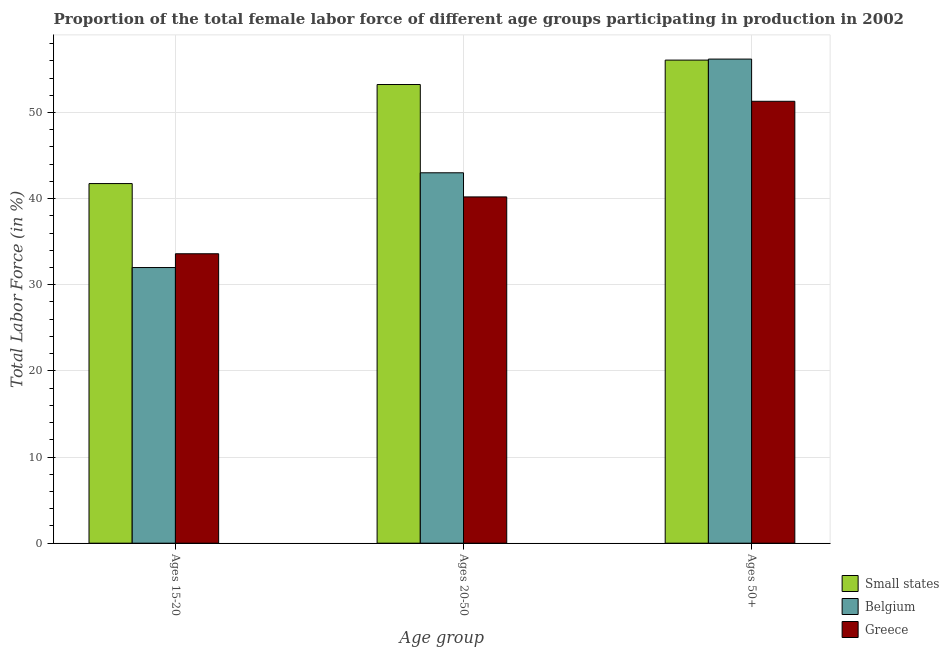How many different coloured bars are there?
Provide a succinct answer. 3. How many groups of bars are there?
Offer a terse response. 3. Are the number of bars on each tick of the X-axis equal?
Offer a terse response. Yes. How many bars are there on the 2nd tick from the left?
Give a very brief answer. 3. How many bars are there on the 3rd tick from the right?
Keep it short and to the point. 3. What is the label of the 1st group of bars from the left?
Provide a short and direct response. Ages 15-20. What is the percentage of female labor force within the age group 20-50 in Small states?
Offer a terse response. 53.25. Across all countries, what is the maximum percentage of female labor force above age 50?
Give a very brief answer. 56.2. In which country was the percentage of female labor force within the age group 20-50 maximum?
Your response must be concise. Small states. What is the total percentage of female labor force within the age group 20-50 in the graph?
Your answer should be very brief. 136.45. What is the difference between the percentage of female labor force above age 50 in Greece and that in Belgium?
Ensure brevity in your answer.  -4.9. What is the difference between the percentage of female labor force within the age group 20-50 in Belgium and the percentage of female labor force above age 50 in Small states?
Your answer should be compact. -13.08. What is the average percentage of female labor force within the age group 20-50 per country?
Give a very brief answer. 45.48. What is the difference between the percentage of female labor force within the age group 15-20 and percentage of female labor force within the age group 20-50 in Greece?
Provide a short and direct response. -6.6. What is the ratio of the percentage of female labor force within the age group 15-20 in Small states to that in Belgium?
Your answer should be compact. 1.3. Is the percentage of female labor force within the age group 20-50 in Belgium less than that in Greece?
Your answer should be very brief. No. Is the difference between the percentage of female labor force within the age group 20-50 in Belgium and Greece greater than the difference between the percentage of female labor force within the age group 15-20 in Belgium and Greece?
Ensure brevity in your answer.  Yes. What is the difference between the highest and the second highest percentage of female labor force above age 50?
Give a very brief answer. 0.12. What is the difference between the highest and the lowest percentage of female labor force above age 50?
Provide a short and direct response. 4.9. In how many countries, is the percentage of female labor force within the age group 20-50 greater than the average percentage of female labor force within the age group 20-50 taken over all countries?
Provide a short and direct response. 1. Is the sum of the percentage of female labor force within the age group 15-20 in Small states and Greece greater than the maximum percentage of female labor force within the age group 20-50 across all countries?
Make the answer very short. Yes. What does the 3rd bar from the right in Ages 15-20 represents?
Offer a terse response. Small states. Are all the bars in the graph horizontal?
Provide a short and direct response. No. What is the difference between two consecutive major ticks on the Y-axis?
Provide a short and direct response. 10. Where does the legend appear in the graph?
Keep it short and to the point. Bottom right. What is the title of the graph?
Keep it short and to the point. Proportion of the total female labor force of different age groups participating in production in 2002. What is the label or title of the X-axis?
Your answer should be very brief. Age group. What is the label or title of the Y-axis?
Give a very brief answer. Total Labor Force (in %). What is the Total Labor Force (in %) of Small states in Ages 15-20?
Provide a succinct answer. 41.75. What is the Total Labor Force (in %) of Greece in Ages 15-20?
Offer a terse response. 33.6. What is the Total Labor Force (in %) of Small states in Ages 20-50?
Provide a short and direct response. 53.25. What is the Total Labor Force (in %) of Greece in Ages 20-50?
Ensure brevity in your answer.  40.2. What is the Total Labor Force (in %) of Small states in Ages 50+?
Your answer should be compact. 56.08. What is the Total Labor Force (in %) in Belgium in Ages 50+?
Make the answer very short. 56.2. What is the Total Labor Force (in %) in Greece in Ages 50+?
Your answer should be very brief. 51.3. Across all Age group, what is the maximum Total Labor Force (in %) in Small states?
Make the answer very short. 56.08. Across all Age group, what is the maximum Total Labor Force (in %) in Belgium?
Offer a very short reply. 56.2. Across all Age group, what is the maximum Total Labor Force (in %) of Greece?
Your answer should be very brief. 51.3. Across all Age group, what is the minimum Total Labor Force (in %) of Small states?
Provide a succinct answer. 41.75. Across all Age group, what is the minimum Total Labor Force (in %) of Belgium?
Ensure brevity in your answer.  32. Across all Age group, what is the minimum Total Labor Force (in %) of Greece?
Provide a short and direct response. 33.6. What is the total Total Labor Force (in %) in Small states in the graph?
Make the answer very short. 151.08. What is the total Total Labor Force (in %) in Belgium in the graph?
Your answer should be compact. 131.2. What is the total Total Labor Force (in %) in Greece in the graph?
Your answer should be very brief. 125.1. What is the difference between the Total Labor Force (in %) of Small states in Ages 15-20 and that in Ages 20-50?
Your answer should be compact. -11.5. What is the difference between the Total Labor Force (in %) in Belgium in Ages 15-20 and that in Ages 20-50?
Ensure brevity in your answer.  -11. What is the difference between the Total Labor Force (in %) of Greece in Ages 15-20 and that in Ages 20-50?
Give a very brief answer. -6.6. What is the difference between the Total Labor Force (in %) in Small states in Ages 15-20 and that in Ages 50+?
Offer a terse response. -14.33. What is the difference between the Total Labor Force (in %) in Belgium in Ages 15-20 and that in Ages 50+?
Ensure brevity in your answer.  -24.2. What is the difference between the Total Labor Force (in %) of Greece in Ages 15-20 and that in Ages 50+?
Give a very brief answer. -17.7. What is the difference between the Total Labor Force (in %) of Small states in Ages 20-50 and that in Ages 50+?
Keep it short and to the point. -2.84. What is the difference between the Total Labor Force (in %) of Greece in Ages 20-50 and that in Ages 50+?
Your answer should be compact. -11.1. What is the difference between the Total Labor Force (in %) in Small states in Ages 15-20 and the Total Labor Force (in %) in Belgium in Ages 20-50?
Provide a succinct answer. -1.25. What is the difference between the Total Labor Force (in %) of Small states in Ages 15-20 and the Total Labor Force (in %) of Greece in Ages 20-50?
Your response must be concise. 1.55. What is the difference between the Total Labor Force (in %) of Small states in Ages 15-20 and the Total Labor Force (in %) of Belgium in Ages 50+?
Give a very brief answer. -14.45. What is the difference between the Total Labor Force (in %) of Small states in Ages 15-20 and the Total Labor Force (in %) of Greece in Ages 50+?
Make the answer very short. -9.55. What is the difference between the Total Labor Force (in %) in Belgium in Ages 15-20 and the Total Labor Force (in %) in Greece in Ages 50+?
Give a very brief answer. -19.3. What is the difference between the Total Labor Force (in %) of Small states in Ages 20-50 and the Total Labor Force (in %) of Belgium in Ages 50+?
Provide a short and direct response. -2.95. What is the difference between the Total Labor Force (in %) in Small states in Ages 20-50 and the Total Labor Force (in %) in Greece in Ages 50+?
Your answer should be compact. 1.95. What is the average Total Labor Force (in %) of Small states per Age group?
Give a very brief answer. 50.36. What is the average Total Labor Force (in %) in Belgium per Age group?
Give a very brief answer. 43.73. What is the average Total Labor Force (in %) in Greece per Age group?
Offer a terse response. 41.7. What is the difference between the Total Labor Force (in %) in Small states and Total Labor Force (in %) in Belgium in Ages 15-20?
Your answer should be compact. 9.75. What is the difference between the Total Labor Force (in %) of Small states and Total Labor Force (in %) of Greece in Ages 15-20?
Your response must be concise. 8.15. What is the difference between the Total Labor Force (in %) in Belgium and Total Labor Force (in %) in Greece in Ages 15-20?
Offer a very short reply. -1.6. What is the difference between the Total Labor Force (in %) of Small states and Total Labor Force (in %) of Belgium in Ages 20-50?
Give a very brief answer. 10.25. What is the difference between the Total Labor Force (in %) of Small states and Total Labor Force (in %) of Greece in Ages 20-50?
Your answer should be very brief. 13.05. What is the difference between the Total Labor Force (in %) in Belgium and Total Labor Force (in %) in Greece in Ages 20-50?
Keep it short and to the point. 2.8. What is the difference between the Total Labor Force (in %) in Small states and Total Labor Force (in %) in Belgium in Ages 50+?
Keep it short and to the point. -0.12. What is the difference between the Total Labor Force (in %) in Small states and Total Labor Force (in %) in Greece in Ages 50+?
Your response must be concise. 4.78. What is the difference between the Total Labor Force (in %) in Belgium and Total Labor Force (in %) in Greece in Ages 50+?
Your response must be concise. 4.9. What is the ratio of the Total Labor Force (in %) of Small states in Ages 15-20 to that in Ages 20-50?
Offer a terse response. 0.78. What is the ratio of the Total Labor Force (in %) of Belgium in Ages 15-20 to that in Ages 20-50?
Keep it short and to the point. 0.74. What is the ratio of the Total Labor Force (in %) of Greece in Ages 15-20 to that in Ages 20-50?
Your answer should be very brief. 0.84. What is the ratio of the Total Labor Force (in %) in Small states in Ages 15-20 to that in Ages 50+?
Offer a very short reply. 0.74. What is the ratio of the Total Labor Force (in %) in Belgium in Ages 15-20 to that in Ages 50+?
Keep it short and to the point. 0.57. What is the ratio of the Total Labor Force (in %) of Greece in Ages 15-20 to that in Ages 50+?
Give a very brief answer. 0.66. What is the ratio of the Total Labor Force (in %) of Small states in Ages 20-50 to that in Ages 50+?
Give a very brief answer. 0.95. What is the ratio of the Total Labor Force (in %) in Belgium in Ages 20-50 to that in Ages 50+?
Your answer should be very brief. 0.77. What is the ratio of the Total Labor Force (in %) in Greece in Ages 20-50 to that in Ages 50+?
Keep it short and to the point. 0.78. What is the difference between the highest and the second highest Total Labor Force (in %) of Small states?
Offer a terse response. 2.84. What is the difference between the highest and the second highest Total Labor Force (in %) of Belgium?
Provide a succinct answer. 13.2. What is the difference between the highest and the second highest Total Labor Force (in %) of Greece?
Make the answer very short. 11.1. What is the difference between the highest and the lowest Total Labor Force (in %) of Small states?
Offer a terse response. 14.33. What is the difference between the highest and the lowest Total Labor Force (in %) in Belgium?
Provide a succinct answer. 24.2. 